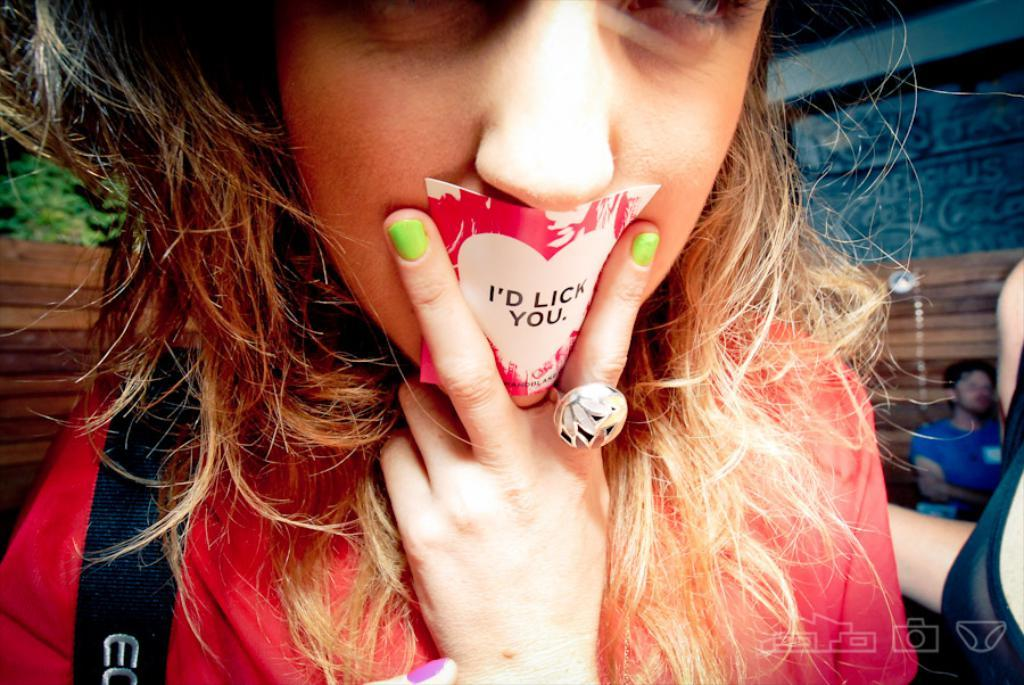What accessory is the woman wearing in the image? The woman is wearing a ring in the image. What object is the woman holding in the image? The woman is holding a sticker in the image. Can you describe the background of the image? The background of the image is blurry, and a tree and a person are visible. Where is the basin located in the image? There is no basin present in the image. How many brothers can be seen in the image? There is no mention of brothers in the image, and only one person is visible in the background. 